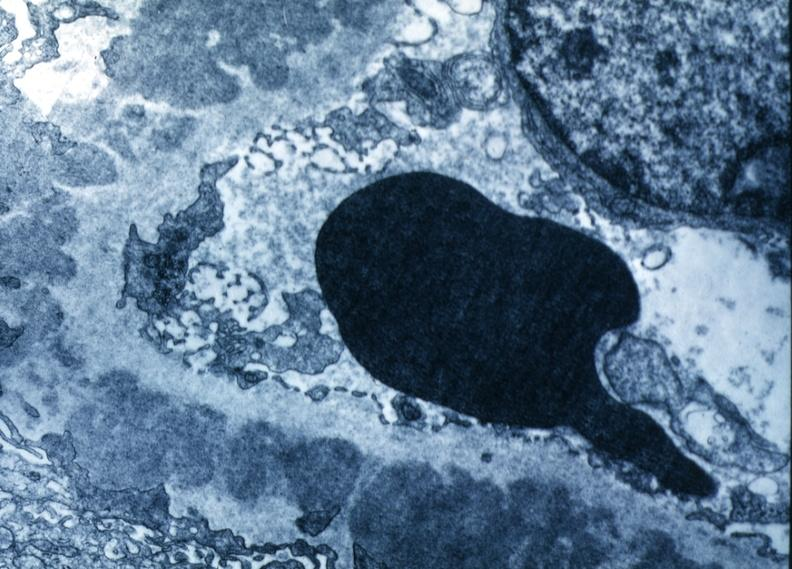what is present?
Answer the question using a single word or phrase. Membranous glomerulonephritis 